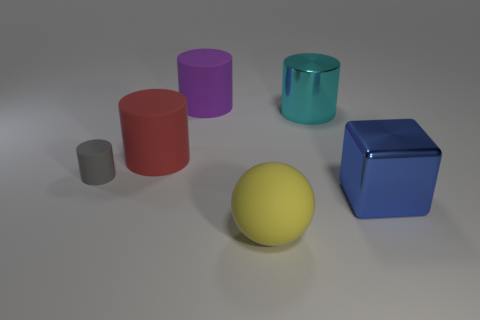What might be the purpose of these objects, and how do you think they are typically used? These objects resemble geometric shapes often used for educational purposes, such as teaching geometry or spatial reasoning. They could also serve as elements in a 3D modeling software tutorial, helping users learn how to create and manipulate basic shapes and understand shading and lighting effects. Could these objects have any artistic significance? Sure, these objects could be part of an abstract art installation or a minimalist composition. The simplicity of forms and the choice of colors might be used to evoke certain emotions or to highlight the interplay of light and shadow, shapes, and distances in a space. 